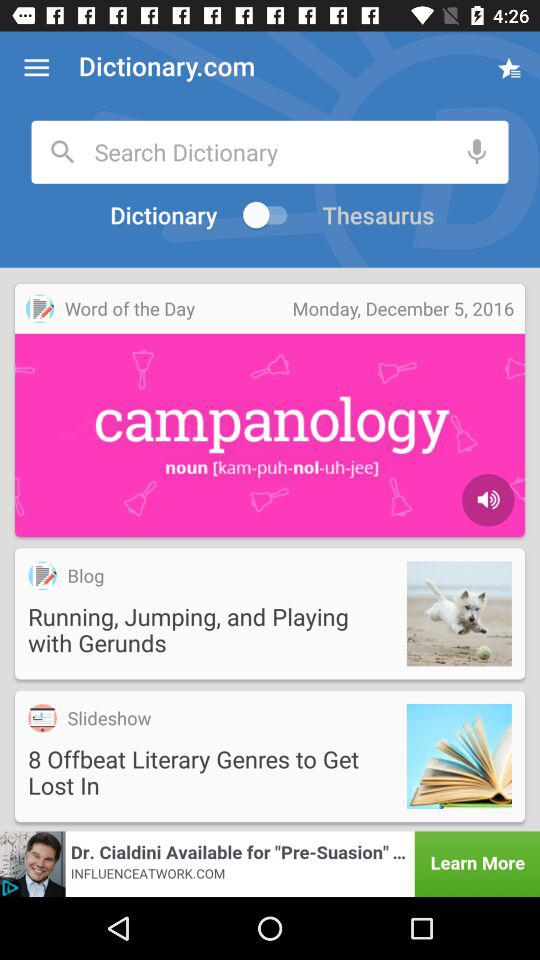What is the word of the day? The word of the day is campanology. 